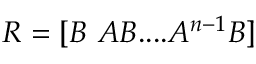Convert formula to latex. <formula><loc_0><loc_0><loc_500><loc_500>R = [ B \ A B \cdots A ^ { n - 1 } B ]</formula> 